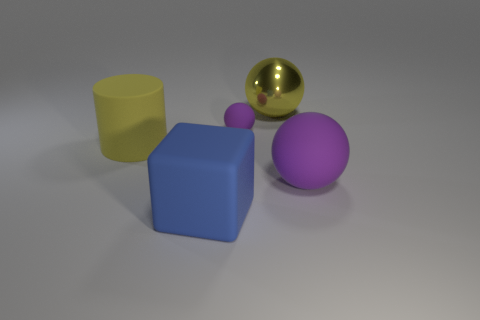Subtract all purple spheres. How many spheres are left? 1 Add 4 large rubber objects. How many objects exist? 9 Subtract 0 red cubes. How many objects are left? 5 Subtract all blocks. How many objects are left? 4 Subtract 1 cylinders. How many cylinders are left? 0 Subtract all red blocks. Subtract all green cylinders. How many blocks are left? 1 Subtract all yellow blocks. How many red cylinders are left? 0 Subtract all small objects. Subtract all yellow cylinders. How many objects are left? 3 Add 2 blue matte cubes. How many blue matte cubes are left? 3 Add 2 tiny purple cylinders. How many tiny purple cylinders exist? 2 